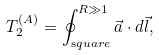<formula> <loc_0><loc_0><loc_500><loc_500>T _ { 2 } ^ { ( A ) } = \oint _ { \mathrm s q u a r e } ^ { R \gg 1 } \vec { a } \cdot d \vec { l } ,</formula> 